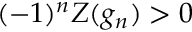Convert formula to latex. <formula><loc_0><loc_0><loc_500><loc_500>( - 1 ) ^ { n } Z ( g _ { n } ) > 0</formula> 